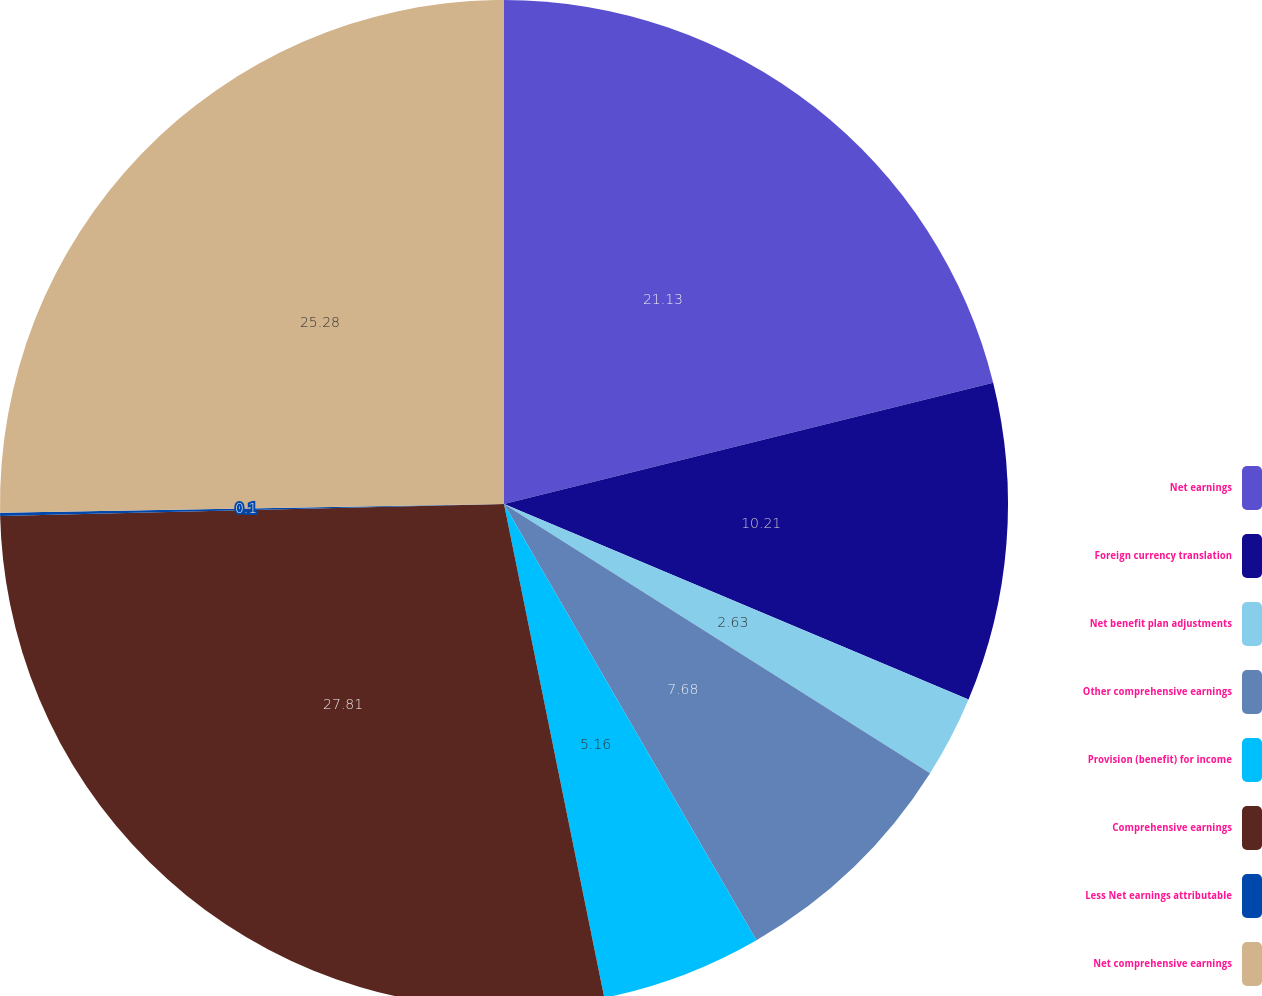<chart> <loc_0><loc_0><loc_500><loc_500><pie_chart><fcel>Net earnings<fcel>Foreign currency translation<fcel>Net benefit plan adjustments<fcel>Other comprehensive earnings<fcel>Provision (benefit) for income<fcel>Comprehensive earnings<fcel>Less Net earnings attributable<fcel>Net comprehensive earnings<nl><fcel>21.13%<fcel>10.21%<fcel>2.63%<fcel>7.68%<fcel>5.16%<fcel>27.81%<fcel>0.1%<fcel>25.28%<nl></chart> 